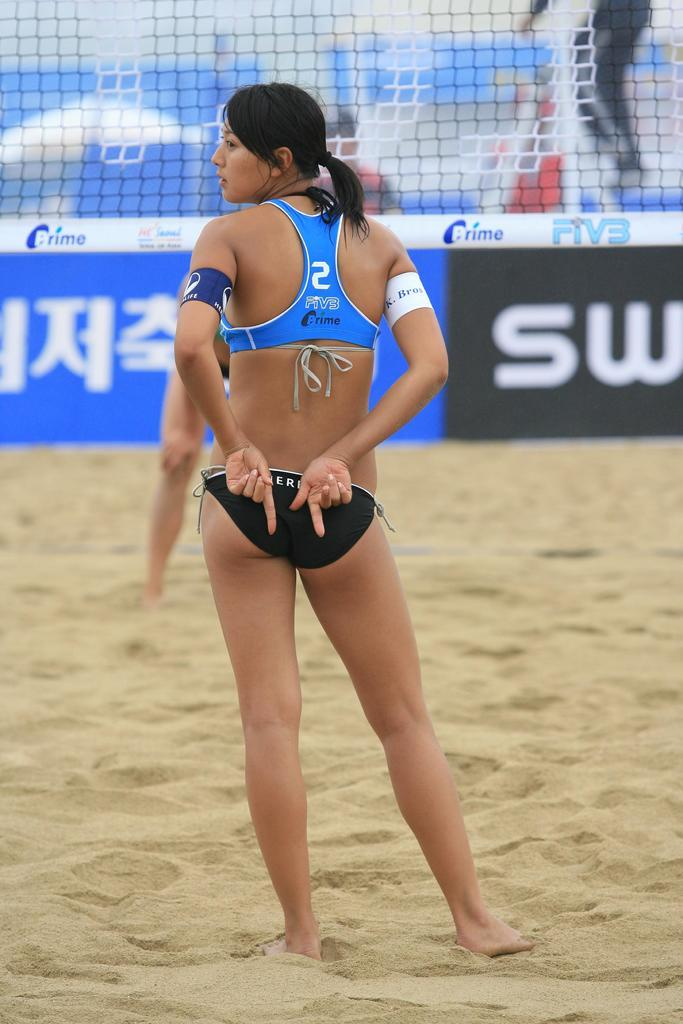<image>
Share a concise interpretation of the image provided. A volleyball player stands in front of the net in a shirt that says 2 PiVB Prime on the back. 